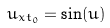Convert formula to latex. <formula><loc_0><loc_0><loc_500><loc_500>u _ { x t _ { 0 } } = \sin ( u )</formula> 